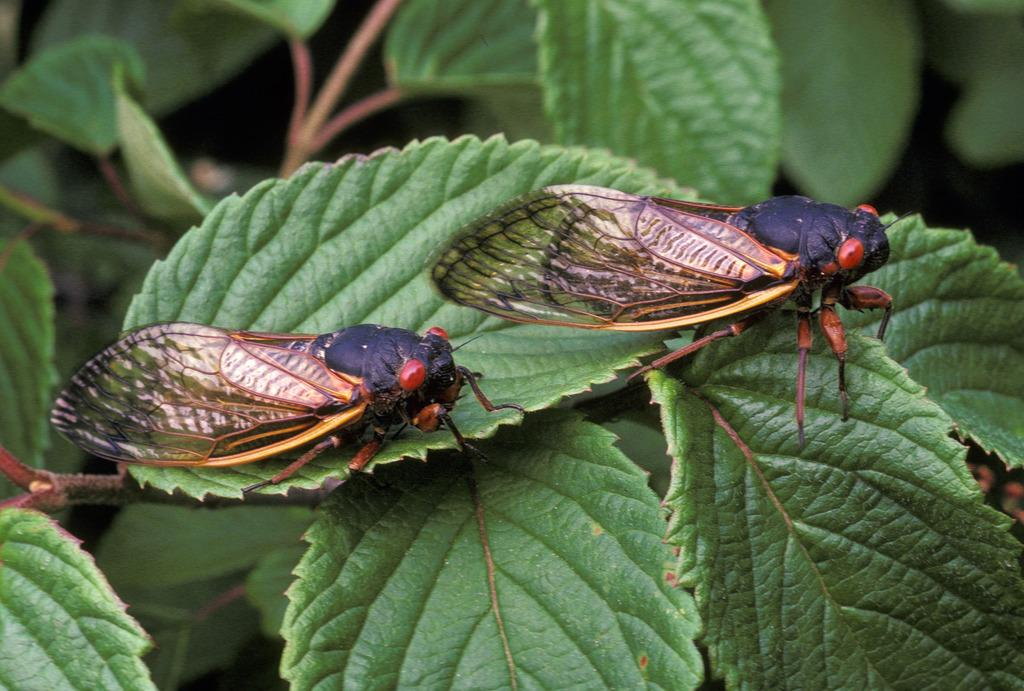How many insects are present in the image? There are two insects in the image. Where are the insects located? The insects are on a leaf. What is the leaf a part of? The leaf belongs to a plant. What colors are the insects in the image? The insects are in black and red color. What is the name of the pipe that the insects are using in the image? There is no pipe present in the image, and the insects are not using any tools or objects. 